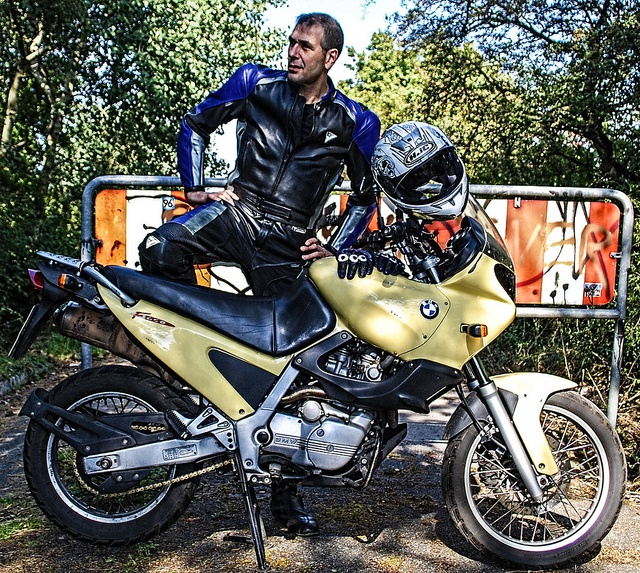Describe the objects in this image and their specific colors. I can see motorcycle in beige, black, white, gray, and khaki tones and people in beige, black, navy, white, and gray tones in this image. 